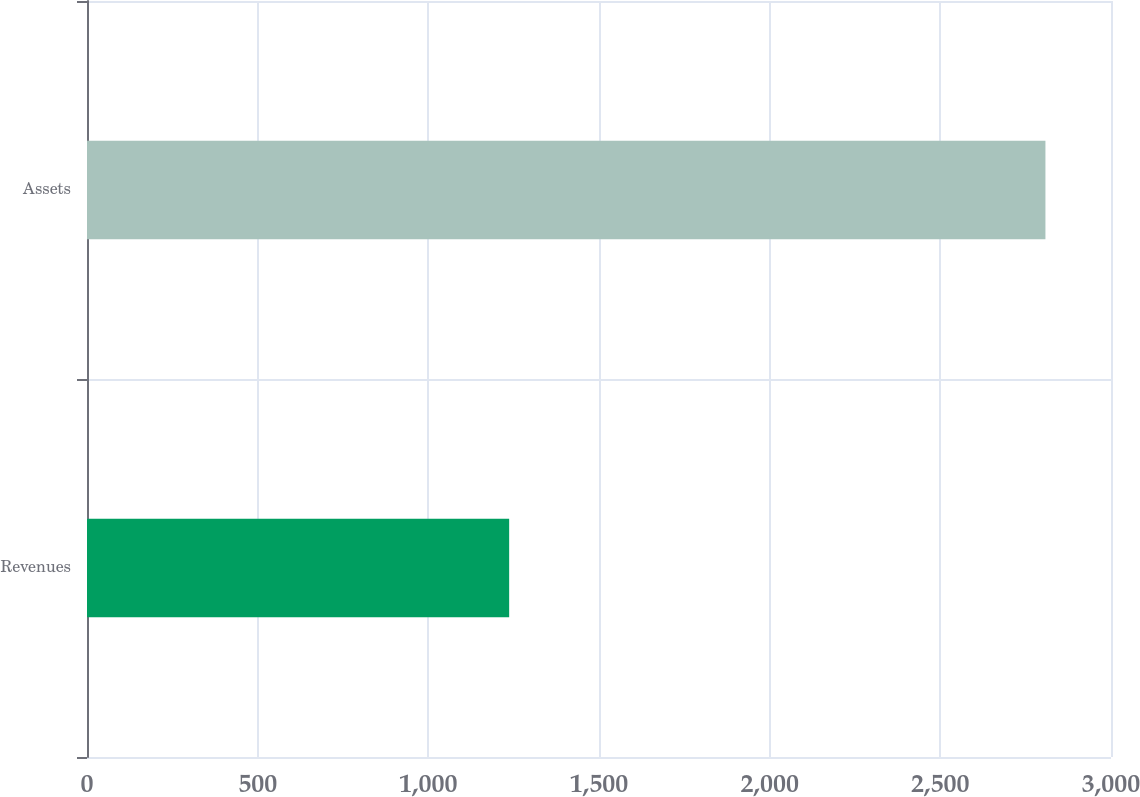<chart> <loc_0><loc_0><loc_500><loc_500><bar_chart><fcel>Revenues<fcel>Assets<nl><fcel>1236.8<fcel>2807.9<nl></chart> 